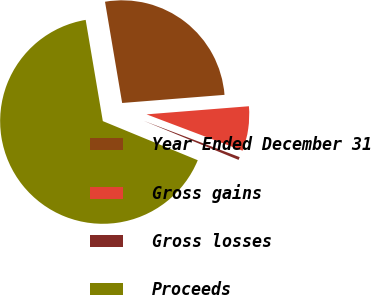Convert chart to OTSL. <chart><loc_0><loc_0><loc_500><loc_500><pie_chart><fcel>Year Ended December 31<fcel>Gross gains<fcel>Gross losses<fcel>Proceeds<nl><fcel>26.41%<fcel>7.02%<fcel>0.46%<fcel>66.11%<nl></chart> 